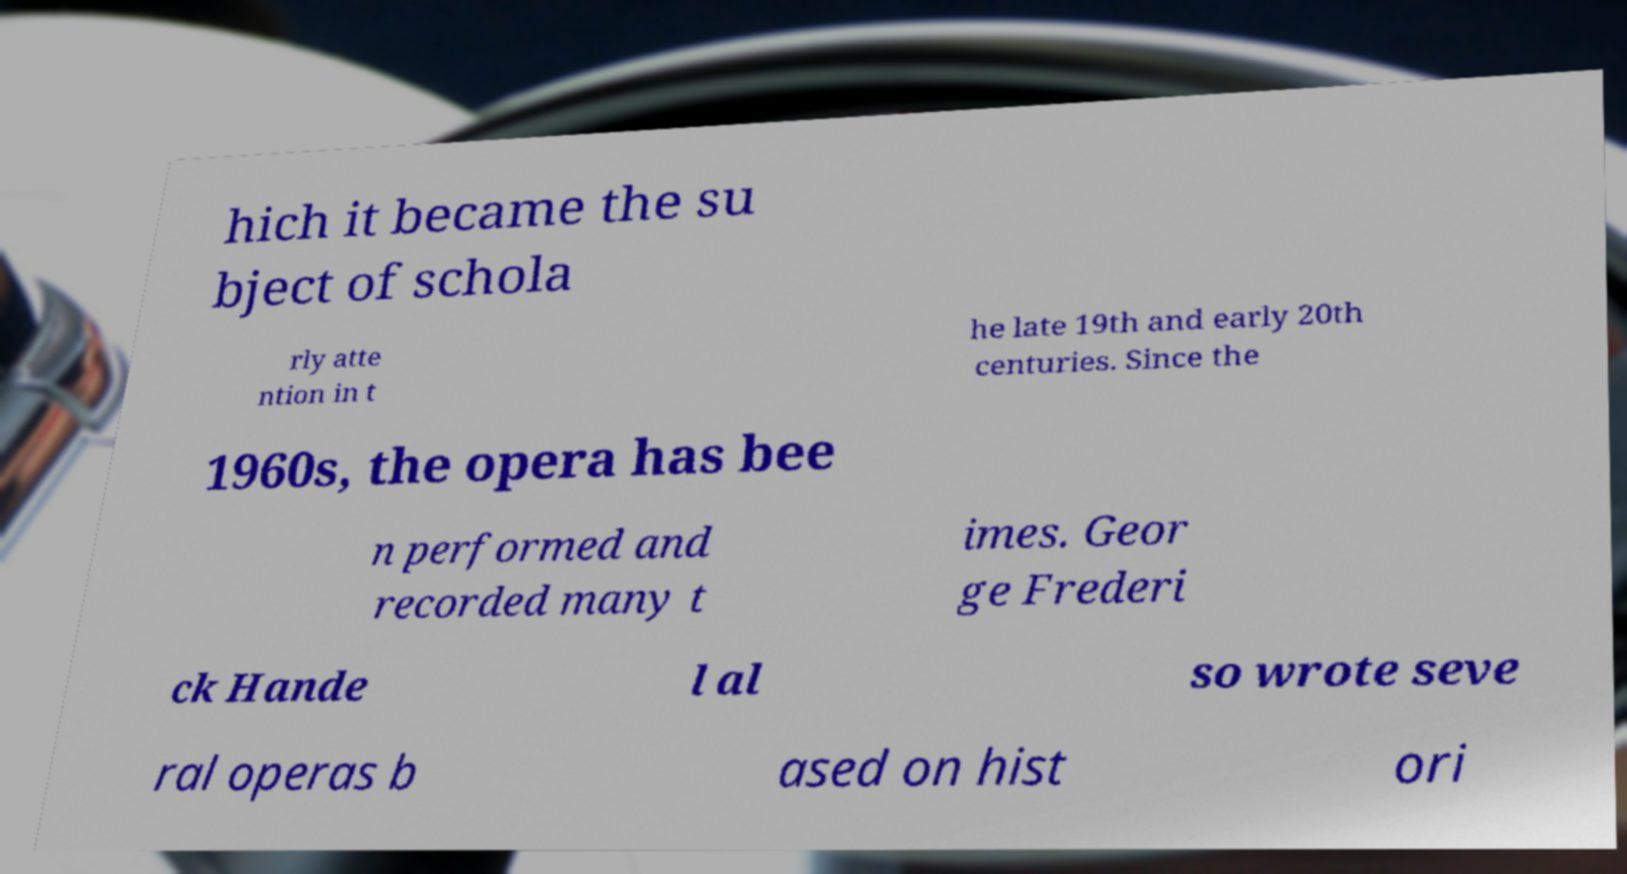Could you assist in decoding the text presented in this image and type it out clearly? hich it became the su bject of schola rly atte ntion in t he late 19th and early 20th centuries. Since the 1960s, the opera has bee n performed and recorded many t imes. Geor ge Frederi ck Hande l al so wrote seve ral operas b ased on hist ori 